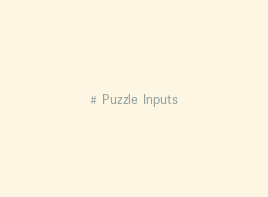<code> <loc_0><loc_0><loc_500><loc_500><_Python_># Puzzle Inputs</code> 